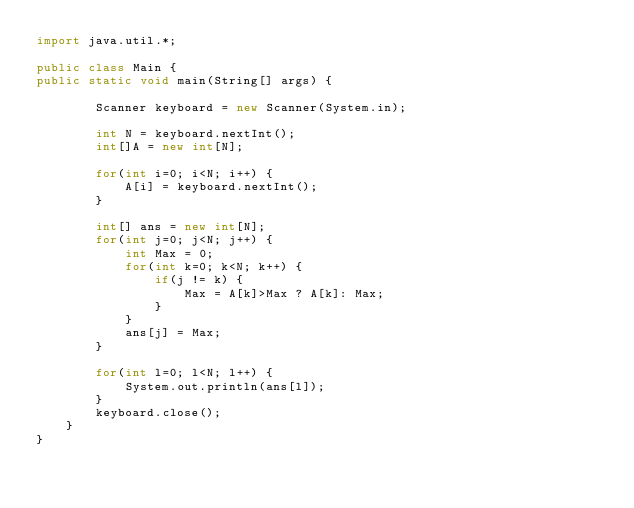Convert code to text. <code><loc_0><loc_0><loc_500><loc_500><_Java_>import java.util.*;

public class Main {
public static void main(String[] args) {
		
		Scanner keyboard = new Scanner(System.in); 
		
		int N = keyboard.nextInt();
		int[]A = new int[N];
		
		for(int i=0; i<N; i++) {
			A[i] = keyboard.nextInt();
		}
		
		int[] ans = new int[N];
		for(int j=0; j<N; j++) {
			int Max = 0;
			for(int k=0; k<N; k++) {
				if(j != k) {
					Max = A[k]>Max ? A[k]: Max;
				}
			}
			ans[j] = Max;
		}
		
		for(int l=0; l<N; l++) {
			System.out.println(ans[l]);
		}
		keyboard.close();	
	}
}
</code> 